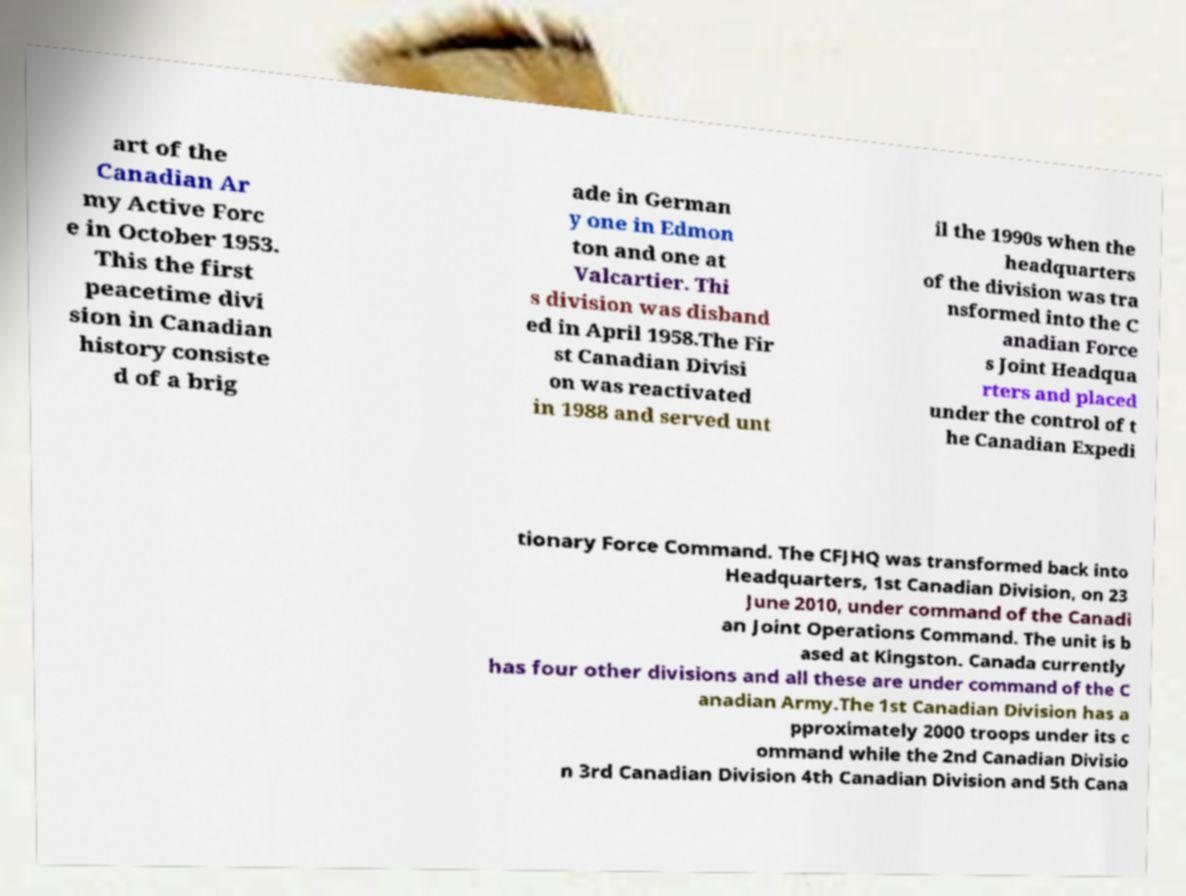Please read and relay the text visible in this image. What does it say? art of the Canadian Ar my Active Forc e in October 1953. This the first peacetime divi sion in Canadian history consiste d of a brig ade in German y one in Edmon ton and one at Valcartier. Thi s division was disband ed in April 1958.The Fir st Canadian Divisi on was reactivated in 1988 and served unt il the 1990s when the headquarters of the division was tra nsformed into the C anadian Force s Joint Headqua rters and placed under the control of t he Canadian Expedi tionary Force Command. The CFJHQ was transformed back into Headquarters, 1st Canadian Division, on 23 June 2010, under command of the Canadi an Joint Operations Command. The unit is b ased at Kingston. Canada currently has four other divisions and all these are under command of the C anadian Army.The 1st Canadian Division has a pproximately 2000 troops under its c ommand while the 2nd Canadian Divisio n 3rd Canadian Division 4th Canadian Division and 5th Cana 